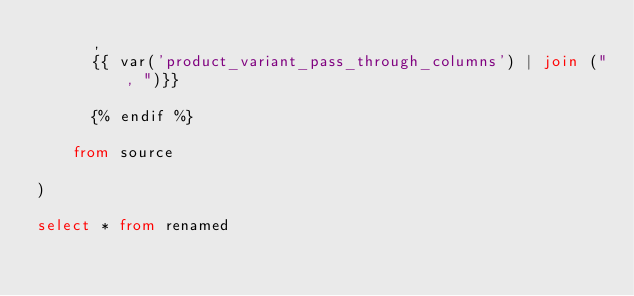Convert code to text. <code><loc_0><loc_0><loc_500><loc_500><_SQL_>      ,
      {{ var('product_variant_pass_through_columns') | join (", ")}}

      {% endif %}

    from source

)

select * from renamed

</code> 